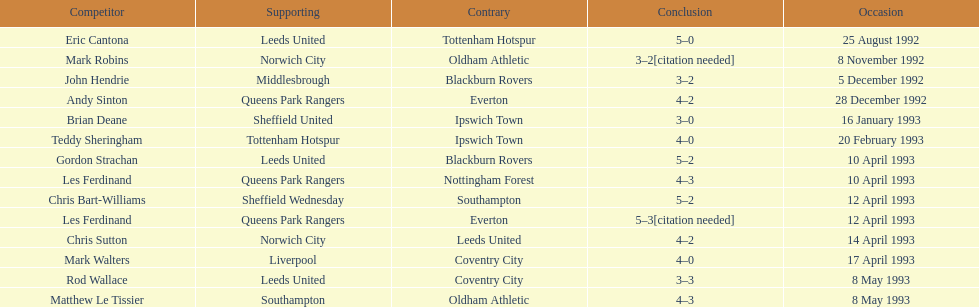Name the players for tottenham hotspur. Teddy Sheringham. 